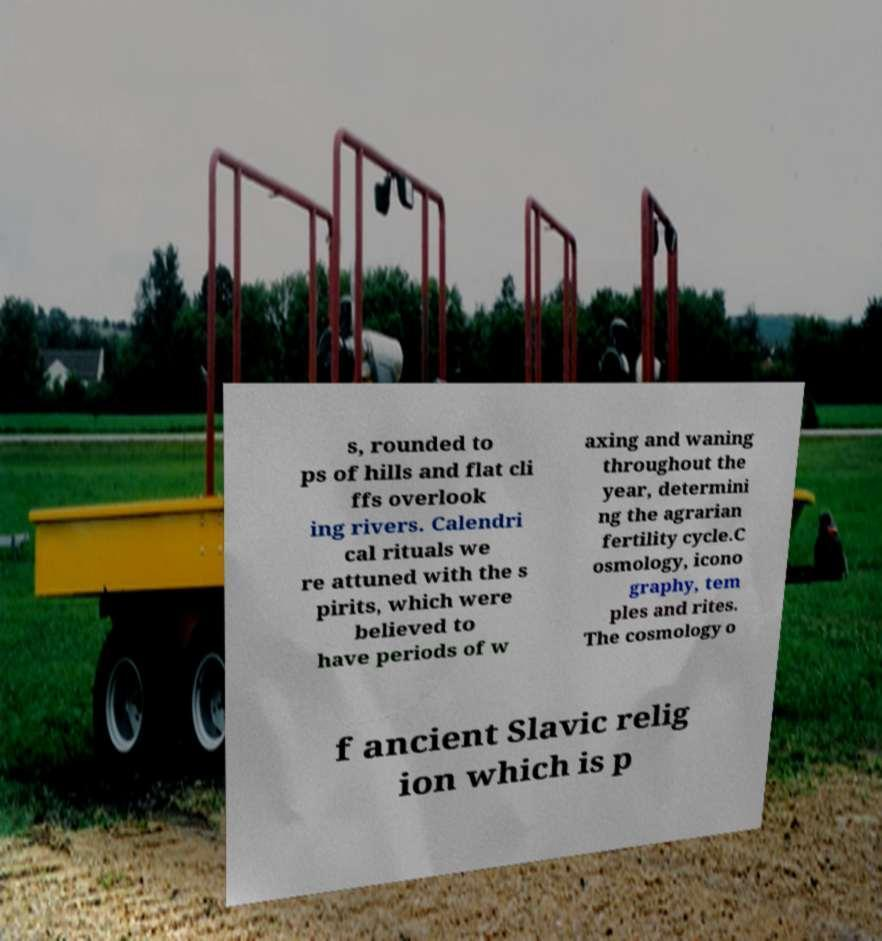For documentation purposes, I need the text within this image transcribed. Could you provide that? s, rounded to ps of hills and flat cli ffs overlook ing rivers. Calendri cal rituals we re attuned with the s pirits, which were believed to have periods of w axing and waning throughout the year, determini ng the agrarian fertility cycle.C osmology, icono graphy, tem ples and rites. The cosmology o f ancient Slavic relig ion which is p 